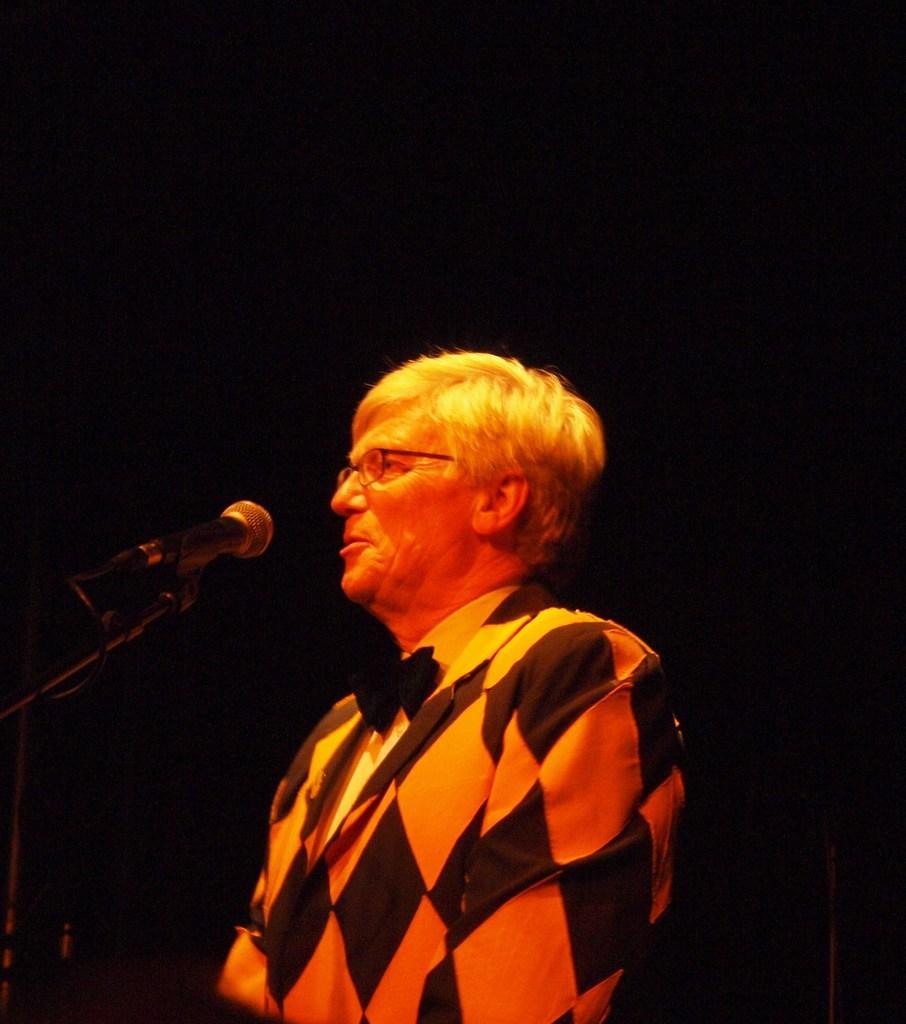How would you summarize this image in a sentence or two? In this image we can see there is a person standing and talking into a microphone. At the back there is a dark background. 